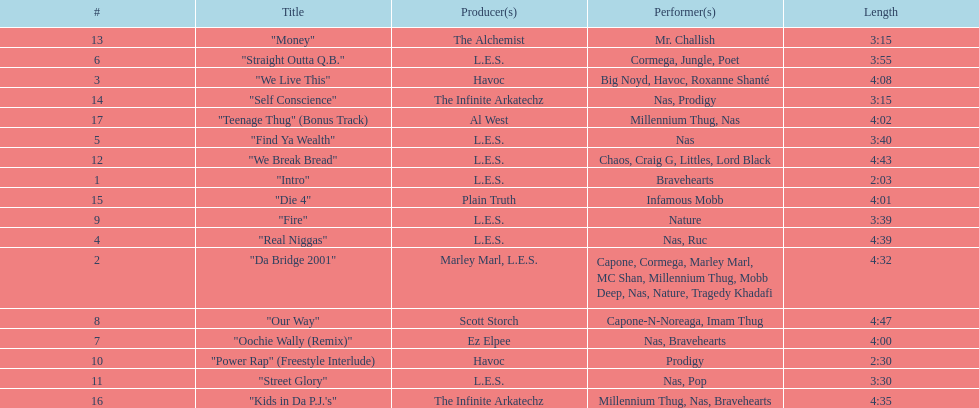How long os the longest track on the album? 4:47. 